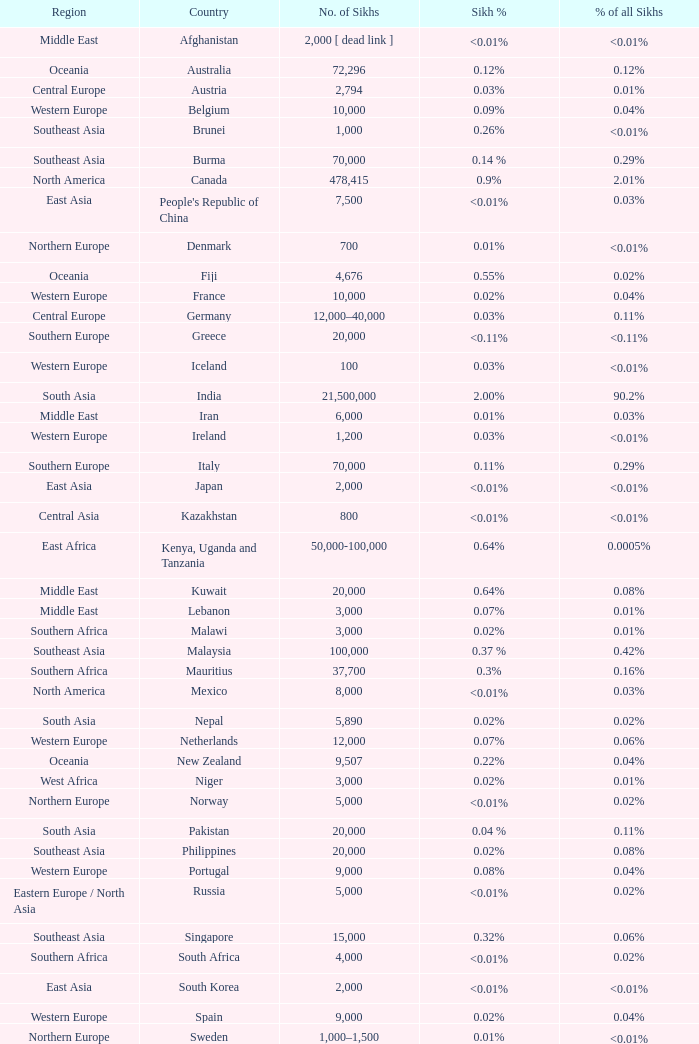How many sikhs are there in japan? 2000.0. 